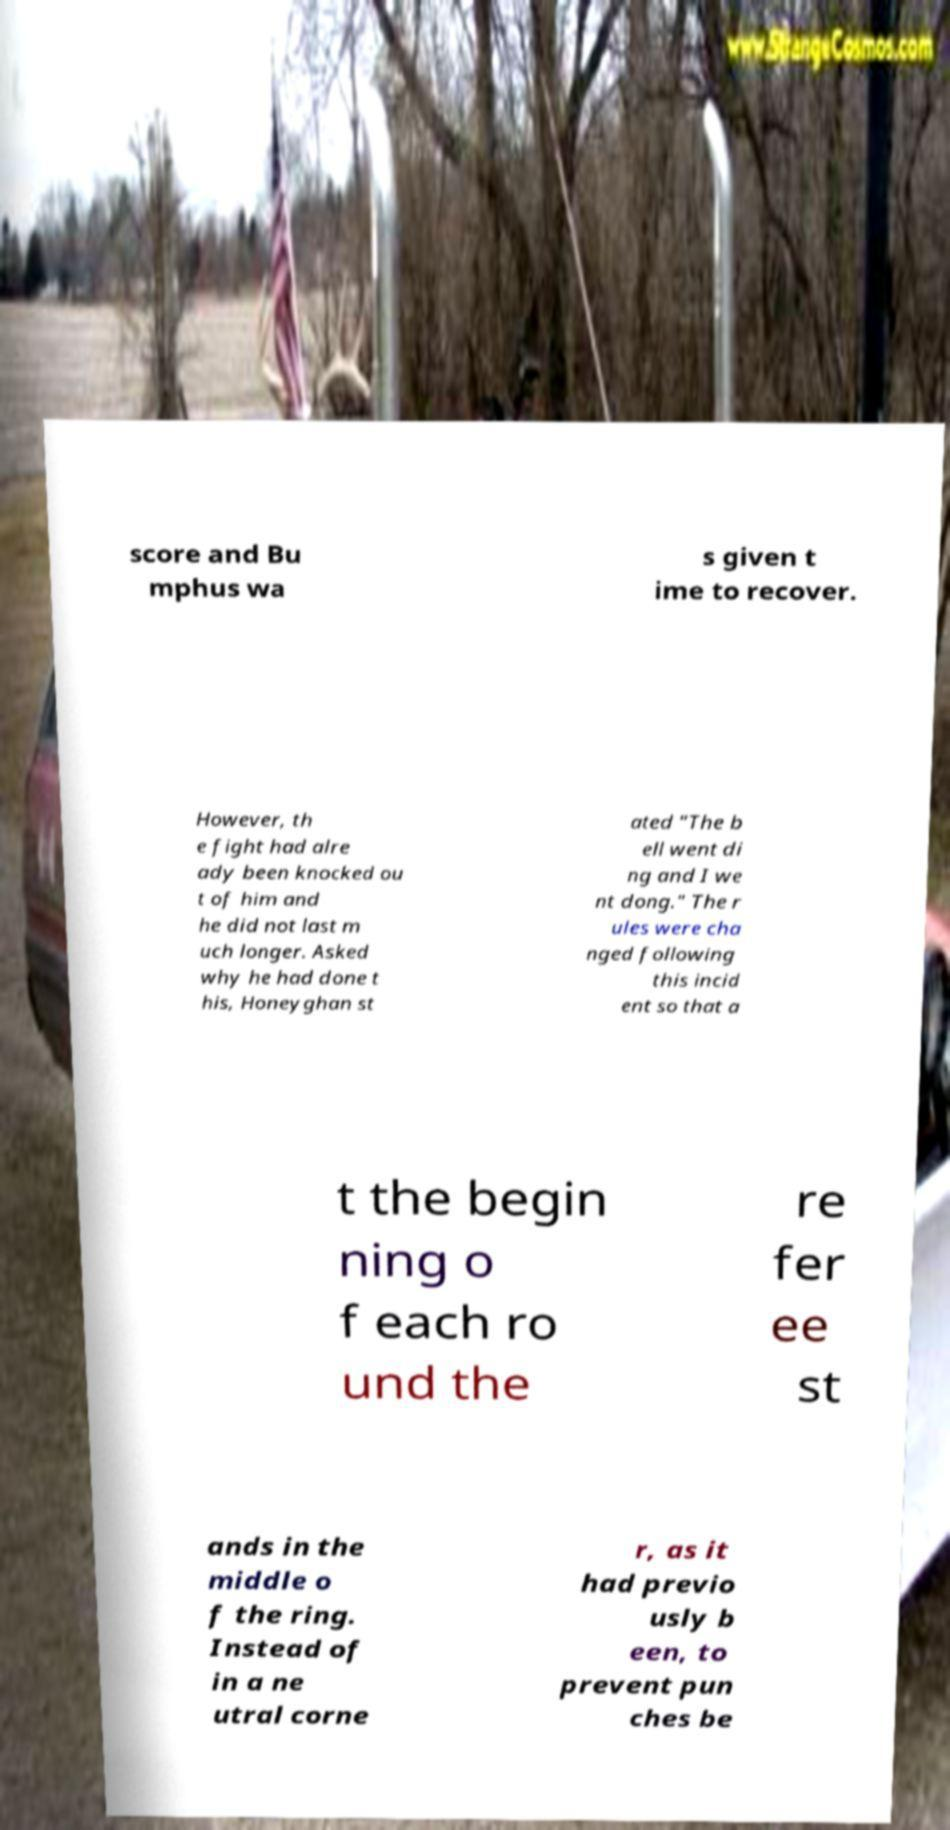For documentation purposes, I need the text within this image transcribed. Could you provide that? score and Bu mphus wa s given t ime to recover. However, th e fight had alre ady been knocked ou t of him and he did not last m uch longer. Asked why he had done t his, Honeyghan st ated "The b ell went di ng and I we nt dong." The r ules were cha nged following this incid ent so that a t the begin ning o f each ro und the re fer ee st ands in the middle o f the ring. Instead of in a ne utral corne r, as it had previo usly b een, to prevent pun ches be 